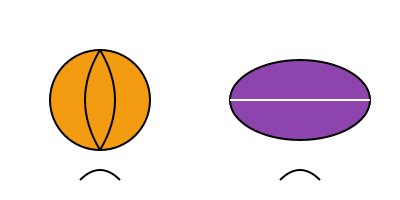Based on the illustration, which sport requires more precise finger control and hand placement for optimal ball handling, and why? To answer this question, we need to consider the following factors:

1. Ball shape:
   - Basketball: Spherical shape
   - Football: Prolate spheroid shape

2. Contact area:
   - Basketball: Larger surface area for hand contact
   - Football: Smaller, more specific contact points

3. Ball control:
   - Basketball: Requires fingertip control for dribbling, passing, and shooting
   - Football: Primarily held with the palm and fingers for throwing

4. Precision requirements:
   - Basketball: 
     a) Dribbling requires constant adjustments and finger control
     b) Shooting demands precise finger placement and release
     c) Passing needs accurate finger control for different types of passes
   - Football:
     a) Throwing requires a specific grip but less constant manipulation
     b) Catching involves more of a "cradle" technique than precise finger control

5. Frequency of ball contact:
   - Basketball: Players are in constant contact with the ball during play
   - Football: Ball contact is less frequent and often involves full-hand grips

Given these factors, basketball requires more precise finger control and hand placement. The constant need for dribbling, quick passes, and accurate shots demands a higher level of fine motor skills and continuous adjustments in finger placement and pressure.
Answer: Basketball requires more precise finger control and hand placement due to constant ball manipulation for dribbling, passing, and shooting. 